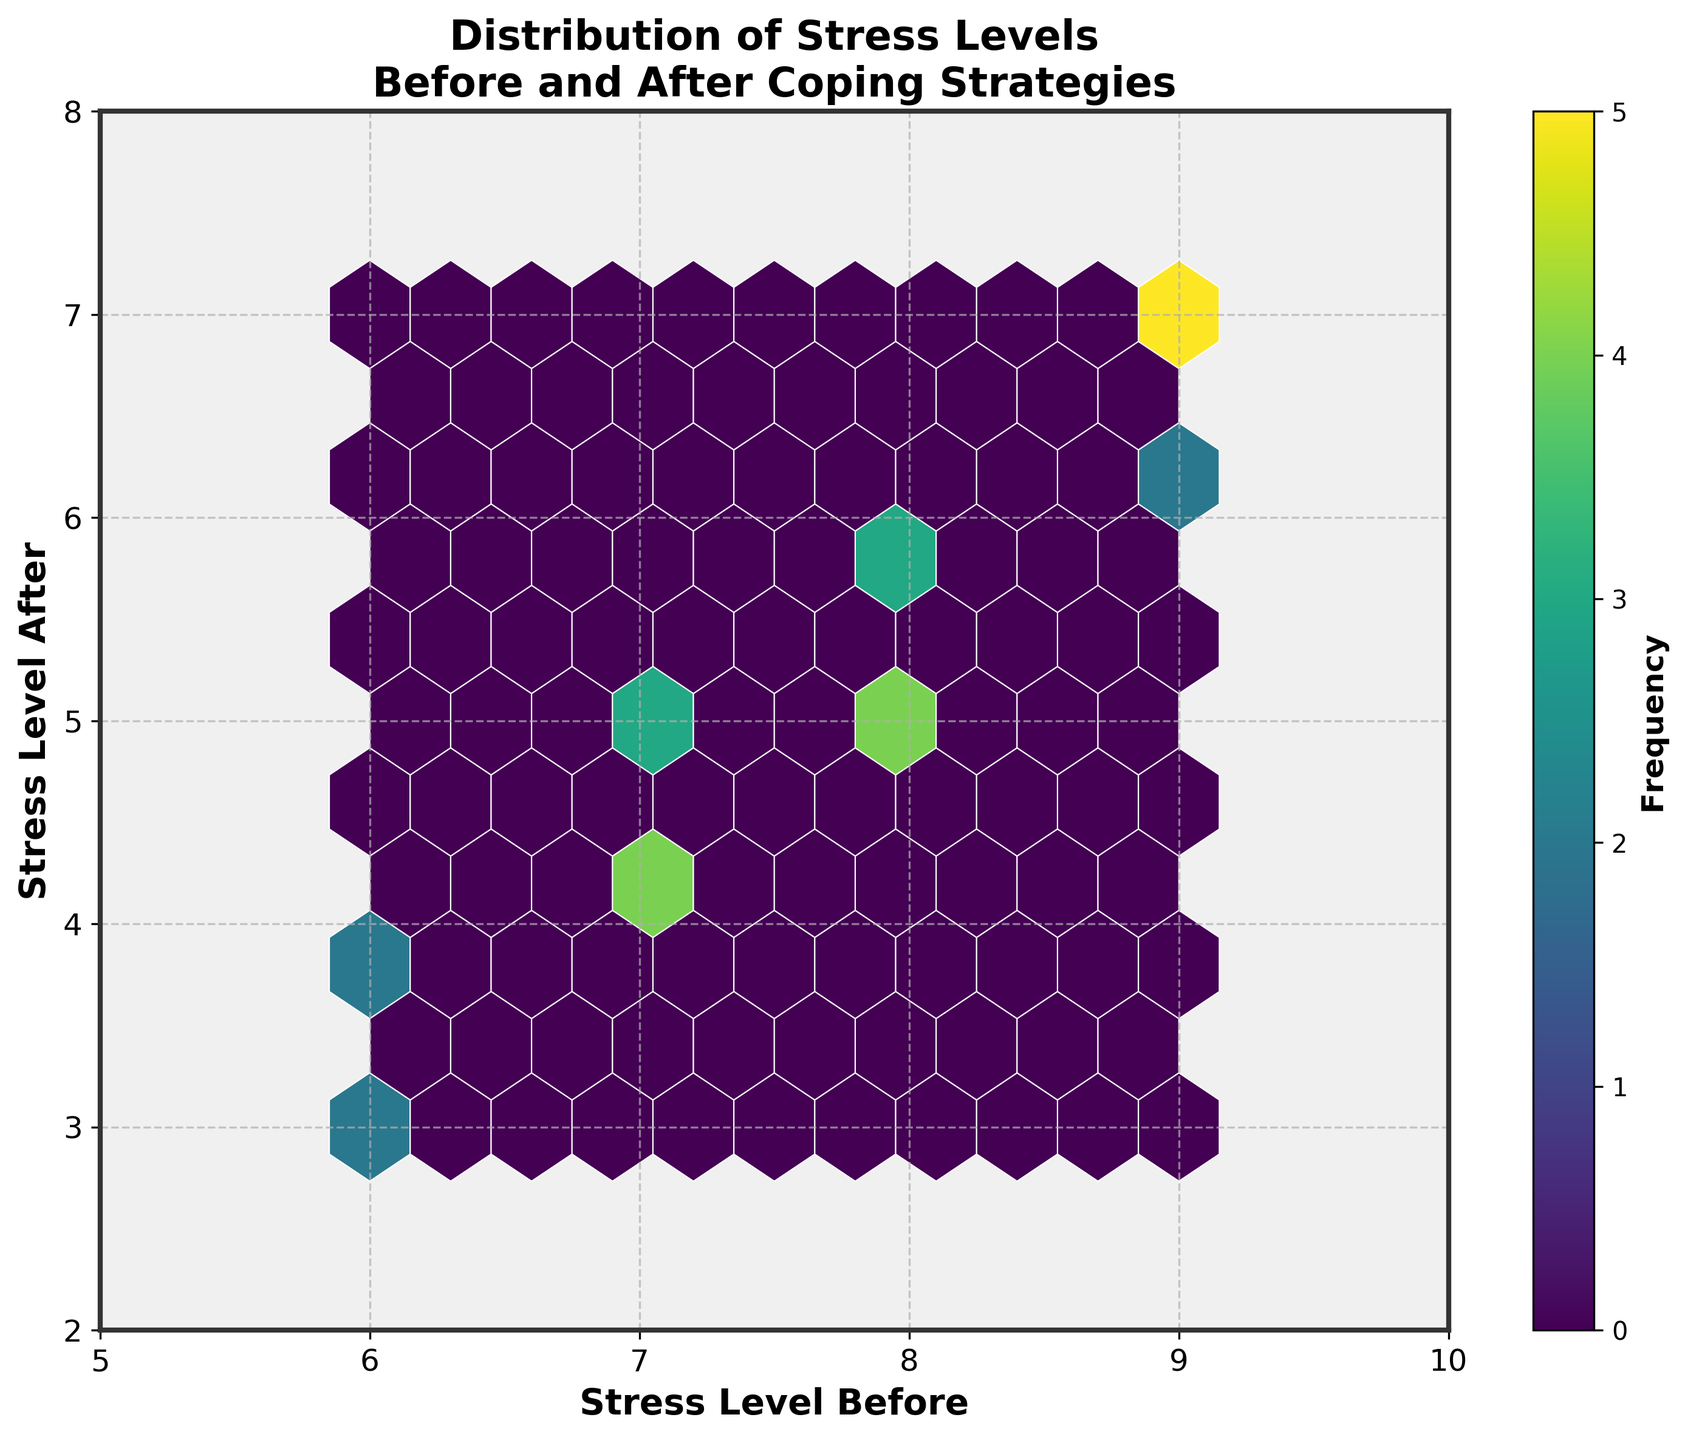what is the title of the figure? The title of a figure is typically found at the top, summarizing the main point or focus of the plot. Here, it is clearly written at the top center of the graph.
Answer: Distribution of Stress Levels Before and After Coping Strategies What are the axes labels of the plot? The axes labels identify what each axis represents. These are usually found along the horizontal (x) and vertical (y) axes. The x-axis label is at the bottom of the plot, and the y-axis label is on the left side.
Answer: Stress Level Before and Stress Level After What is the color of the hexagons in the plot? The color of the hexagons represents the frequency of data points within each hexagon. As seen in the plot's legend, the colors range from light to dark shades of a specific color.
Answer: Different shades of green How does the frequency of the hexagons change as we move to different parts of the plot? The frequency changes based on the density of data points in specific areas. This is visualized by color intensity, with darker colors indicating higher frequencies. Here, we see darker hexagons where stress levels both before and after coping strategies are high.
Answer: Darker hexagons indicate higher frequencies Which range of 'Stress Level Before' has the most data points? By examining the darker hexagons on the x-axis, we can determine which range has the highest concentration of data points. The x-axis ranges from 5 to 10, and the highest frequency appears within the 7-9 range.
Answer: 7-9 What is the general trend observed in the relationship between 'Stress Level Before' and 'Stress Level After'? By looking at the overall pattern of the hexagons, we can infer whether there is a positive or negative trend. In this plot, most of the data points form a diagonal line from the top left to the bottom right, indicating a consistent reduction in stress levels after implementing coping strategies.
Answer: Negative trend How many hexagons have a stress level before of 8 and stress level after of 5? The hexagons' color intensity tells us about the frequency of occurrences in specific regions of the plot. By locating the specific hexagon at these coordinates and examining its shade, we can estimate the frequency.
Answer: One or two hexagons Which coping strategies resulted in the highest reduction in stress levels? The highest reduction can be observed by tracking the change from higher to significantly lower levels on the plot. The hexagons near the bottom right represent the highest reductions in stress levels before and after coping strategies.
Answer: Nature walks and Volunteering What does the color bar in the figure represent? The color bar, usually placed on the right side of the plot, explains the color gradient used. In this hexbin plot, it indicates the frequency of data points within each hexagon.
Answer: Frequency Between 'Stress Level Before' values 6 and 9, which has the widest range of 'Stress Level After'? We compare vertical distributions for 'Stress Level Before' of 6 against 9. By examining the height of the hexagonic columns, 'Stress Level Before' of 9 has a wider range of 'Stress Level After', from 5 to 7.
Answer: 9 